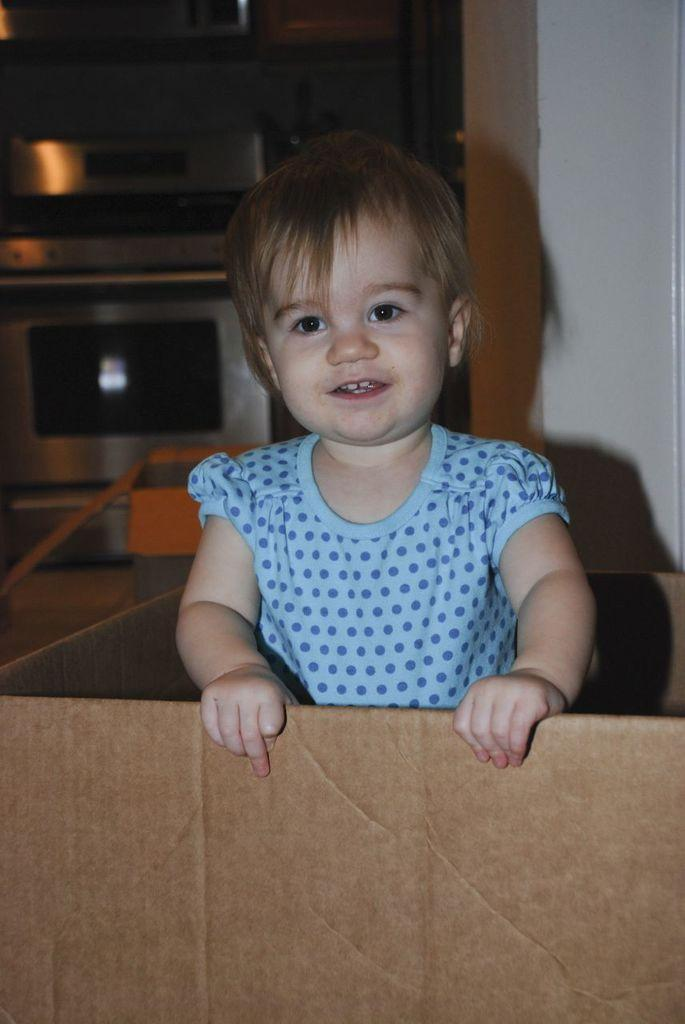What is the main subject of the image? There is a person in the image. Where is the person located? The person is inside a box. What can be seen behind the person? There are objects visible behind the person. What is in the background of the image? There is a wall in the background of the image. What type of drum is the person playing in the image? There is no drum present in the image; the person is inside a box. What discovery was made by the person in the image? There is no indication of a discovery in the image; it simply shows a person inside a box with objects visible behind them and a wall in the background. 